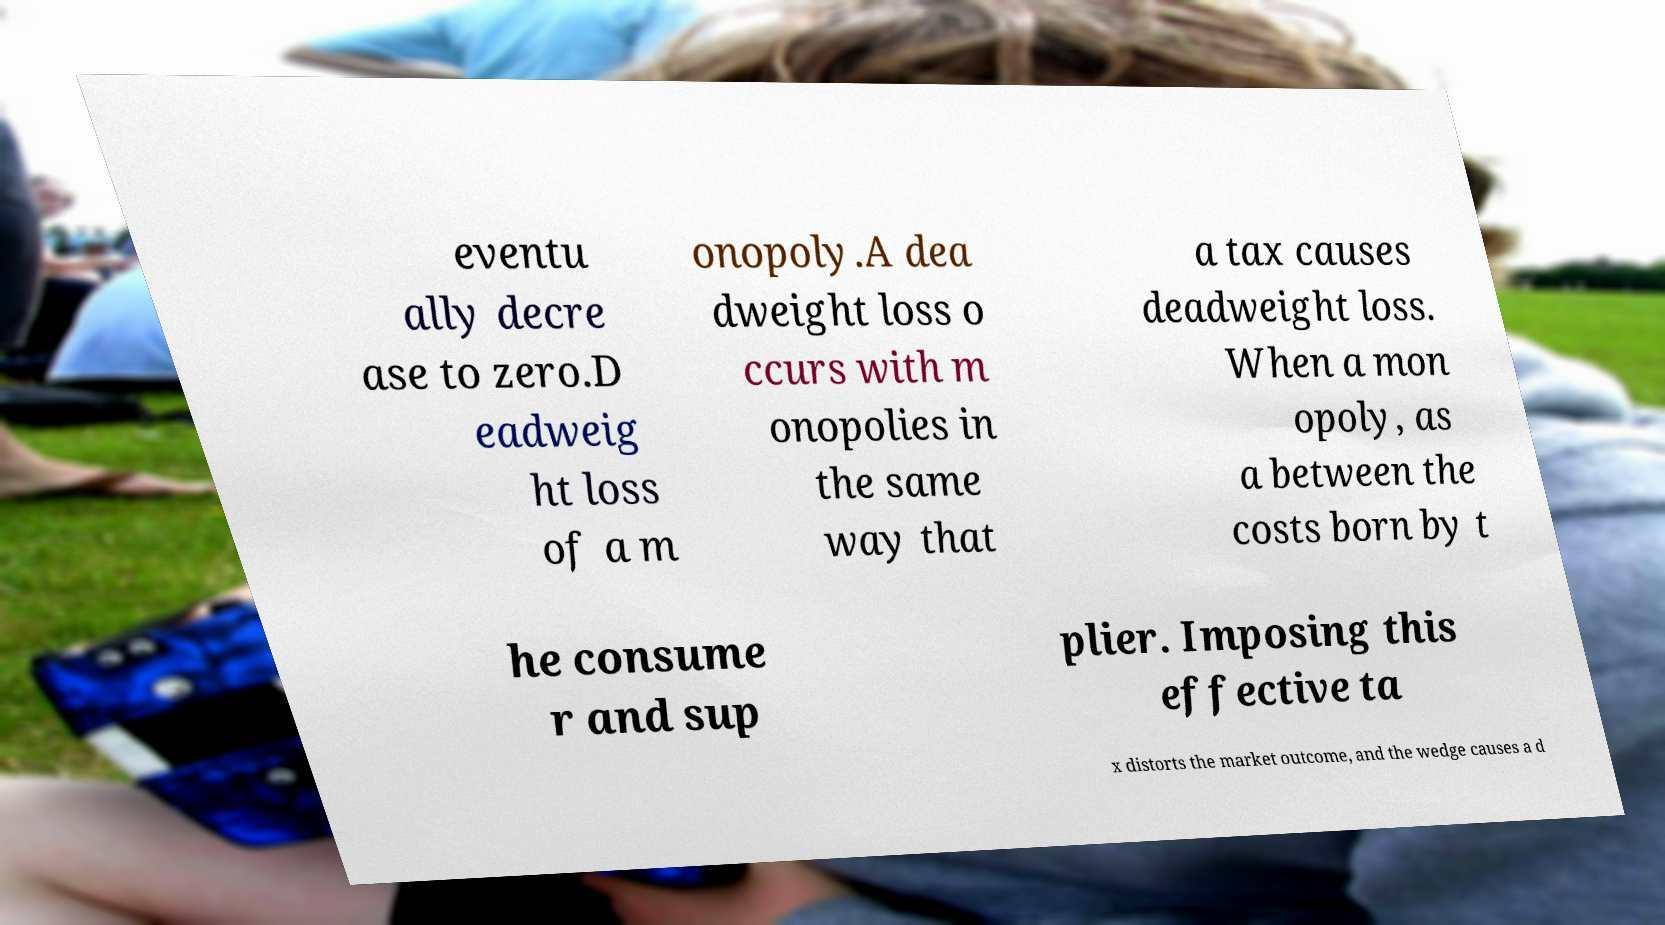Could you extract and type out the text from this image? eventu ally decre ase to zero.D eadweig ht loss of a m onopoly.A dea dweight loss o ccurs with m onopolies in the same way that a tax causes deadweight loss. When a mon opoly, as a between the costs born by t he consume r and sup plier. Imposing this effective ta x distorts the market outcome, and the wedge causes a d 